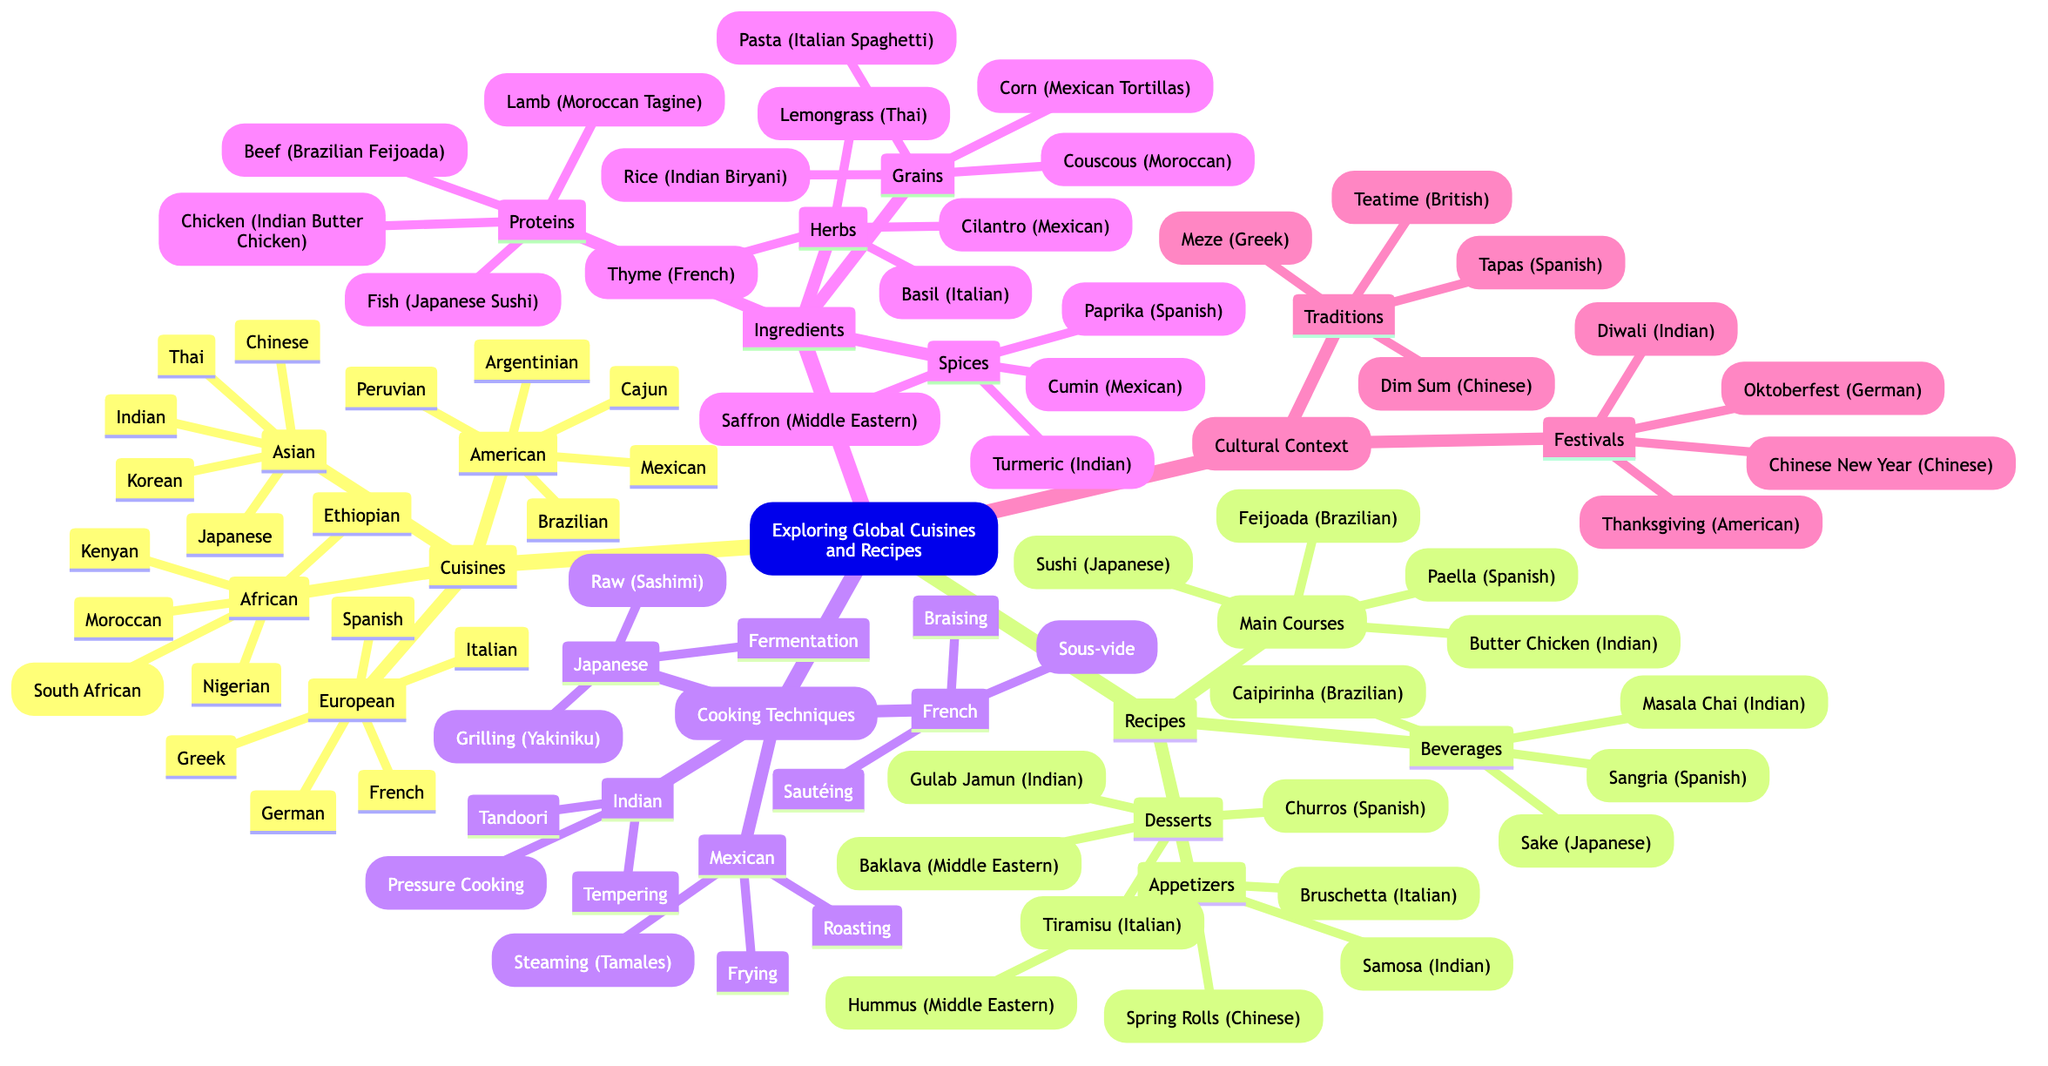What are the four main branches in the diagram? The main branches listed in the diagram are Cuisines, Recipes, Cooking Techniques, Ingredients, and Cultural Context. Counting these gives a total of five main branches.
Answer: Cuisines, Recipes, Cooking Techniques, Ingredients, Cultural Context How many Asian cuisines are represented? The diagram lists five Asian cuisines: Indian, Chinese, Thai, Japanese, and Korean. Counting these gives the answer.
Answer: 5 Which recipe category includes 'Tiramisu'? 'Tiramisu' is listed under the Desserts category within the Recipes branch. The relationship is one of inclusion, as Tiramisu is one of the items in Desserts.
Answer: Desserts What cooking technique is unique to Mexican cuisine in the diagram? The diagram lists 'Steaming (Tamales)' as a unique cooking technique specific to Mexican cuisine, as it is not found in the other branches.
Answer: Steaming (Tamales) Which ingredients are categorized under Spices? The Spices category lists Turmeric, Cumin, Paprika, and Saffron, directly taken from the sub-branches.
Answer: Turmeric, Cumin, Paprika, Saffron What is the connection between 'Diwali' and 'Indian'? 'Diwali' is listed as a festival representative of the Indian cultural context, indicating a specific cultural event tied to Indian cuisine and traditions.
Answer: Festival Which type of cuisine has the recipe ‘Butter Chicken’? The 'Butter Chicken' recipe falls under the Main Courses category within the Recipes branch, and it is specifically categorized as Indian cuisine.
Answer: Indian If we consider beverages, which one is associated with Spanish culture? The diagram lists 'Sangria' under the Beverages category and links it to Spanish cuisine. This indicates a specific beverage tied to that cultural context.
Answer: Sangria How many types of proteins are mentioned in the diagram? The Proteins category lists four types: Chicken, Fish, Beef, and Lamb. Counting these gives the total.
Answer: 4 Which culinary technique is associated with both Japanese and French cuisines? The diagram does not list any cooking techniques that are directly shared between Japanese and French cuisines; each cuisine has unique techniques listed under their respective branches. Therefore, the answer highlights the absence of overlap.
Answer: None 